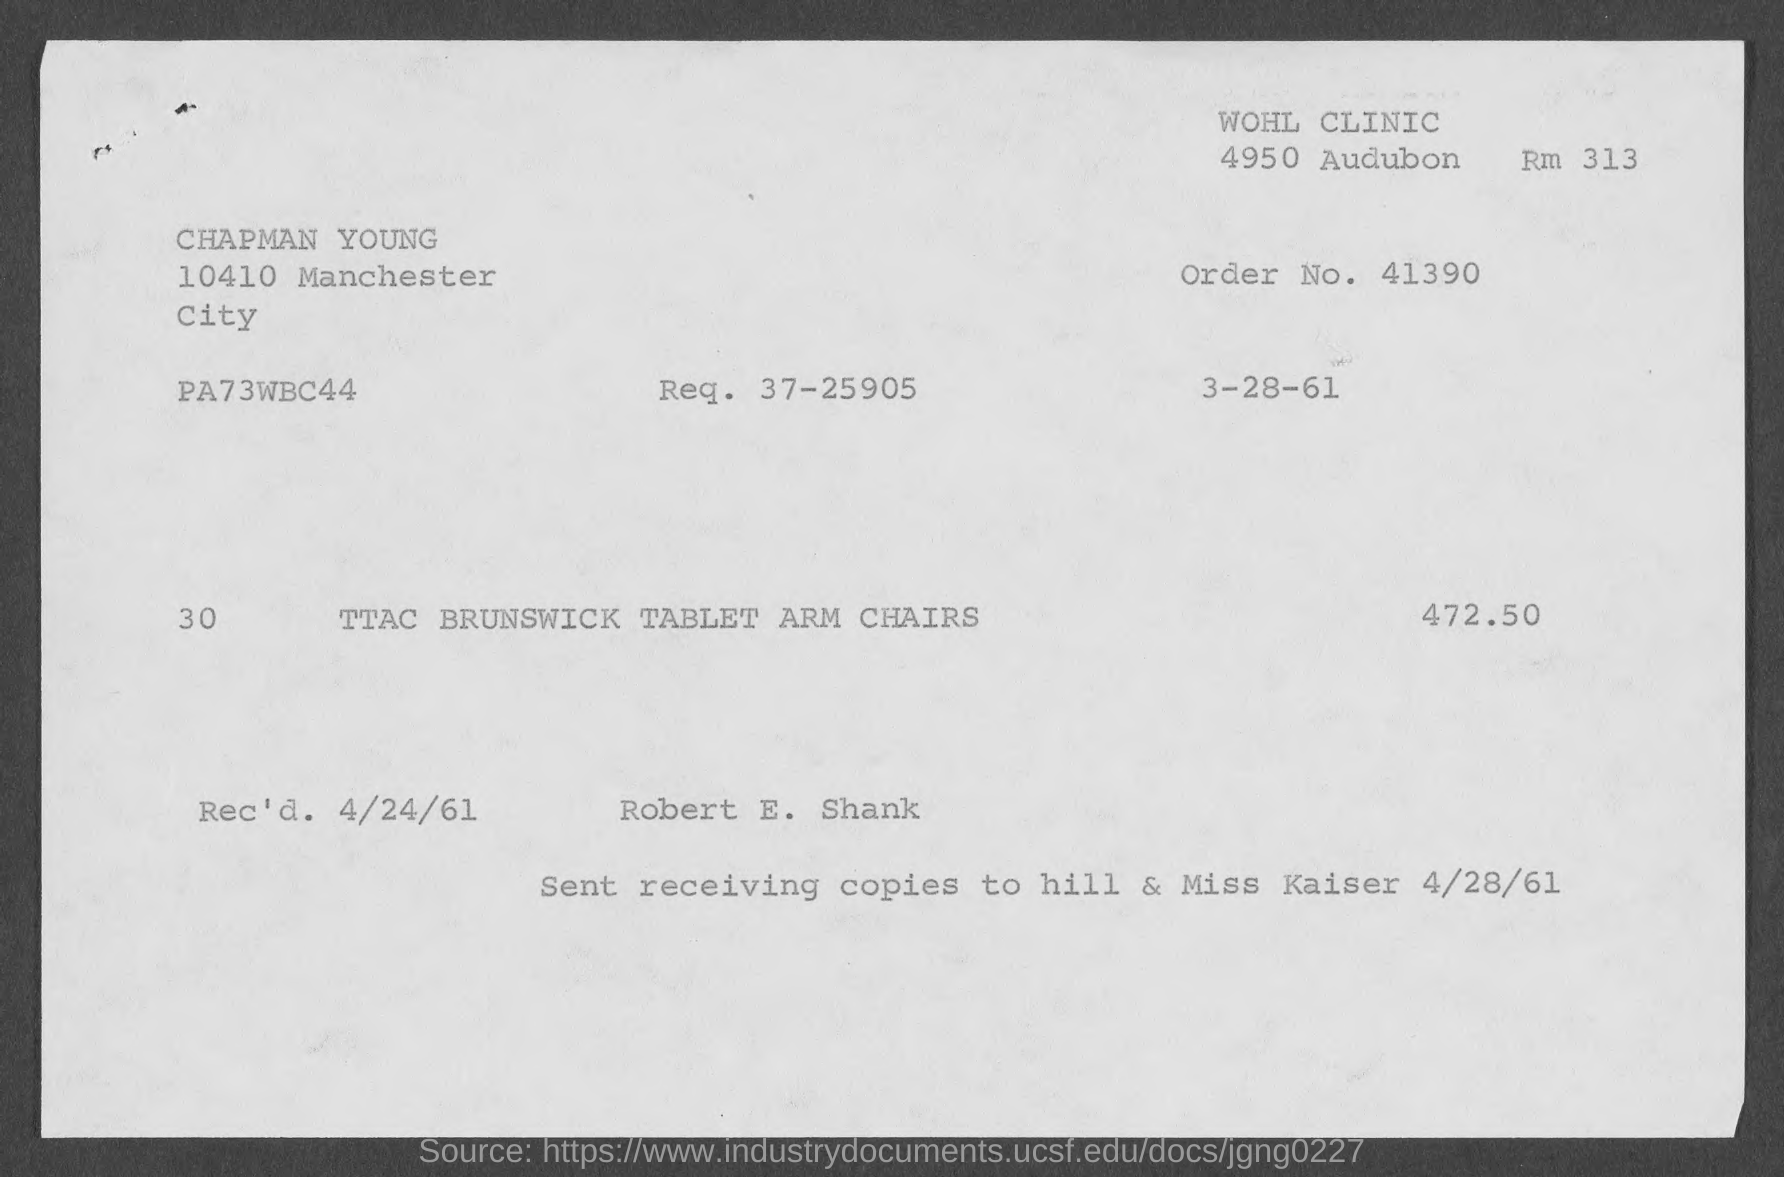Point out several critical features in this image. The amount mentioned in the given form is 472.50... The requested number mentioned in the provided page is 37-25905. The order number mentioned on the given page is 41390. The received date mentioned on the given page is April 24, 1961. 